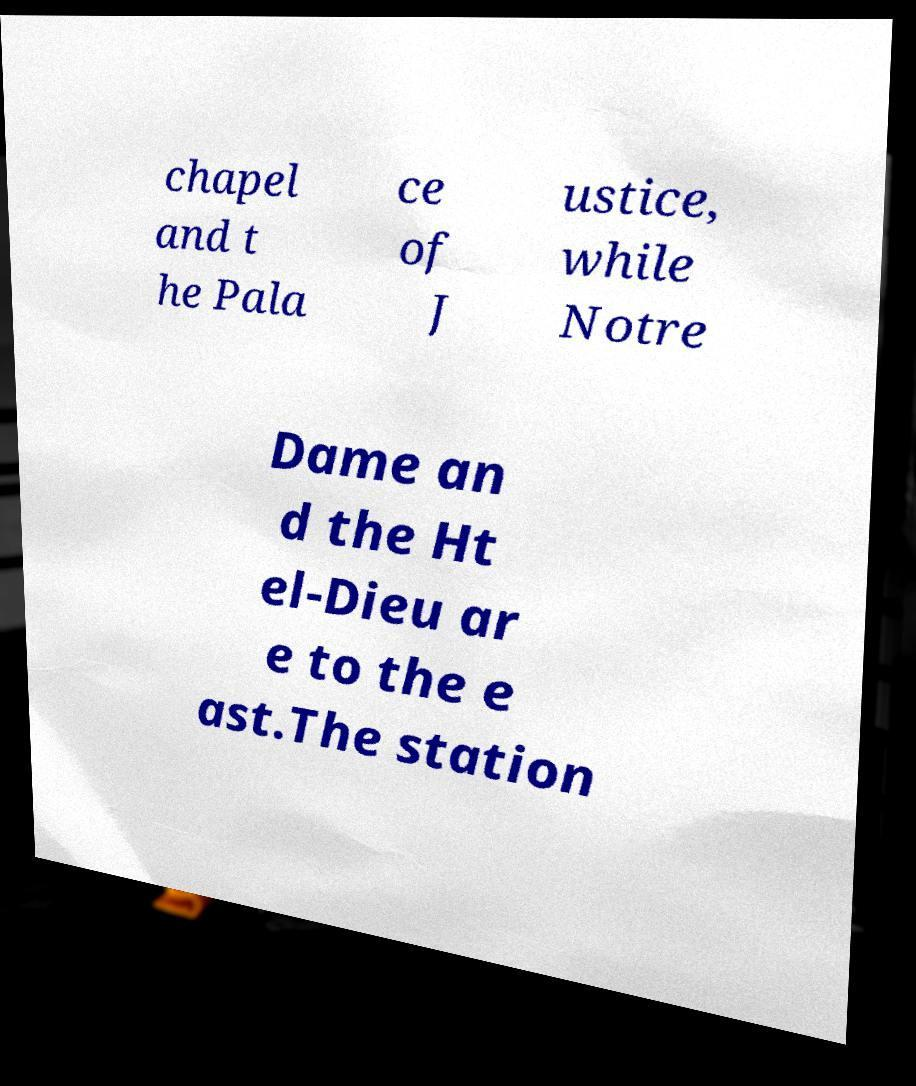For documentation purposes, I need the text within this image transcribed. Could you provide that? chapel and t he Pala ce of J ustice, while Notre Dame an d the Ht el-Dieu ar e to the e ast.The station 